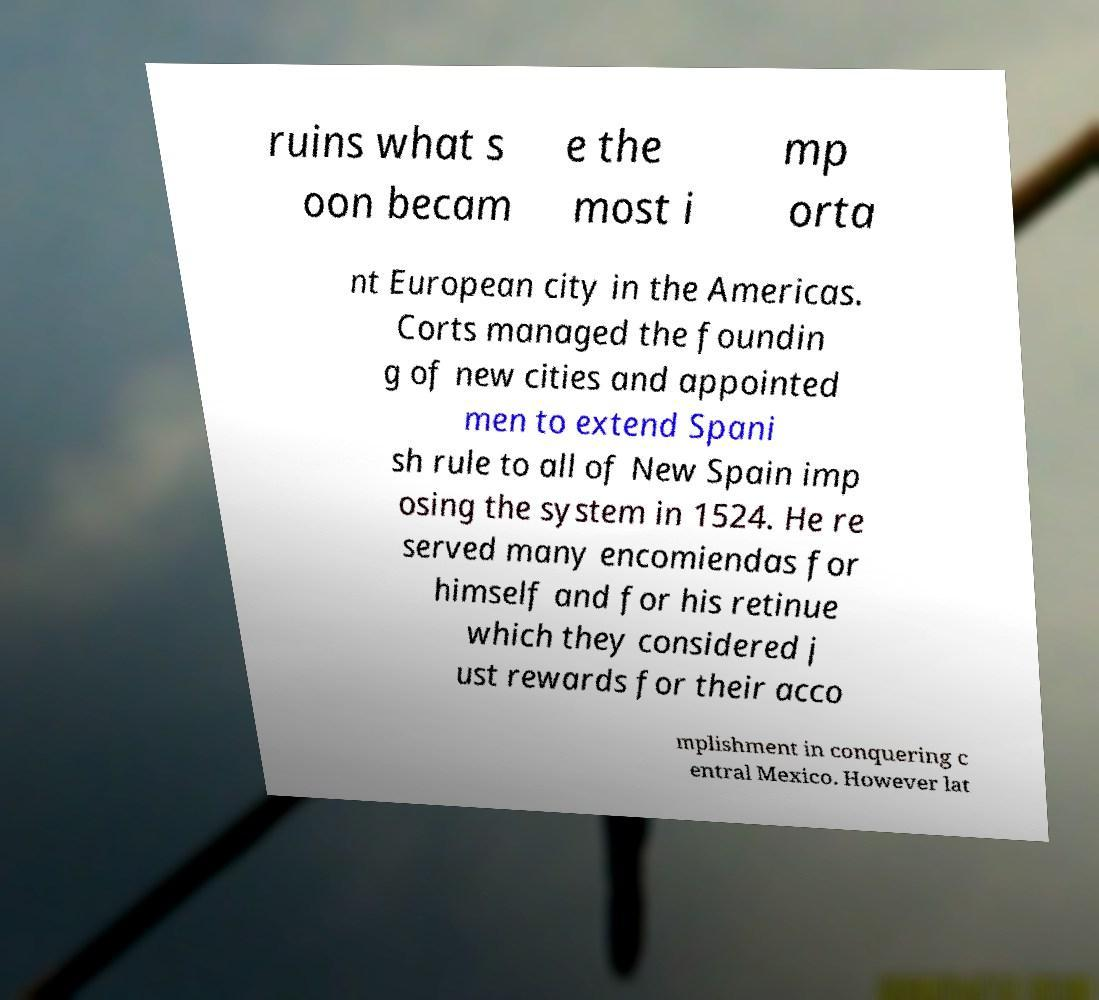There's text embedded in this image that I need extracted. Can you transcribe it verbatim? ruins what s oon becam e the most i mp orta nt European city in the Americas. Corts managed the foundin g of new cities and appointed men to extend Spani sh rule to all of New Spain imp osing the system in 1524. He re served many encomiendas for himself and for his retinue which they considered j ust rewards for their acco mplishment in conquering c entral Mexico. However lat 